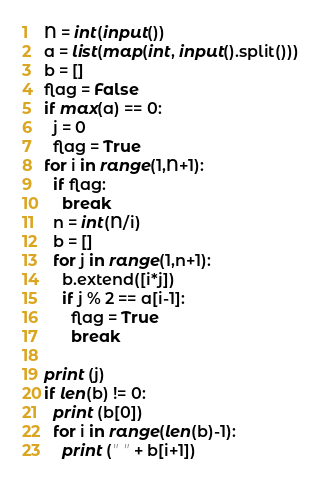Convert code to text. <code><loc_0><loc_0><loc_500><loc_500><_Python_>N = int(input())
a = list(map(int, input().split()))
b = []
flag = False
if max(a) == 0:
  j = 0
  flag = True
for i in range(1,N+1):
  if flag:
    break
  n = int(N/i)
  b = []
  for j in range(1,n+1):
    b.extend([i*j])
    if j % 2 == a[i-1]:
      flag = True
      break

print (j)
if len(b) != 0:
  print (b[0])
  for i in range(len(b)-1):
    print (" " + b[i+1])</code> 